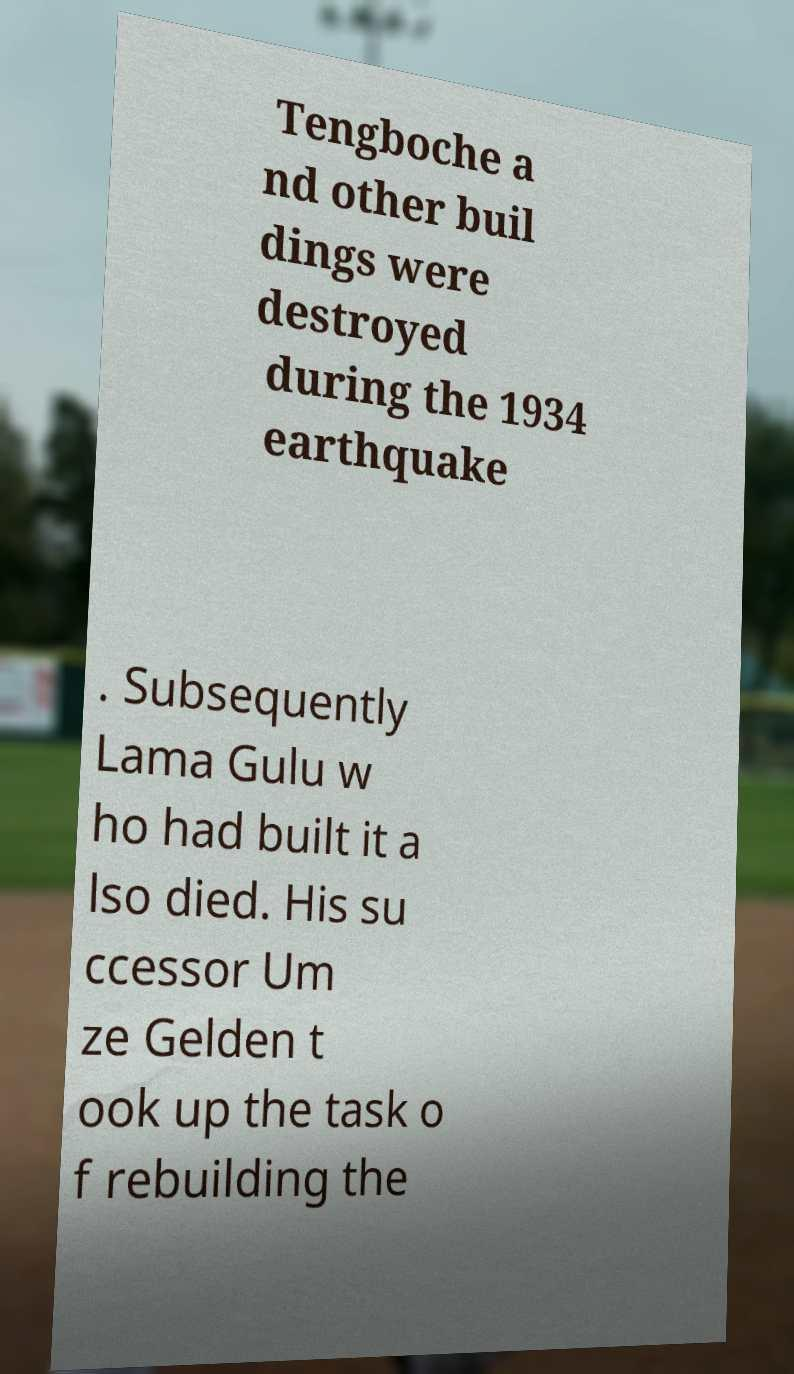There's text embedded in this image that I need extracted. Can you transcribe it verbatim? Tengboche a nd other buil dings were destroyed during the 1934 earthquake . Subsequently Lama Gulu w ho had built it a lso died. His su ccessor Um ze Gelden t ook up the task o f rebuilding the 